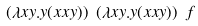<formula> <loc_0><loc_0><loc_500><loc_500>( \lambda x y . y ( x x y ) ) \ ( \lambda x y . y ( x x y ) ) \ f</formula> 